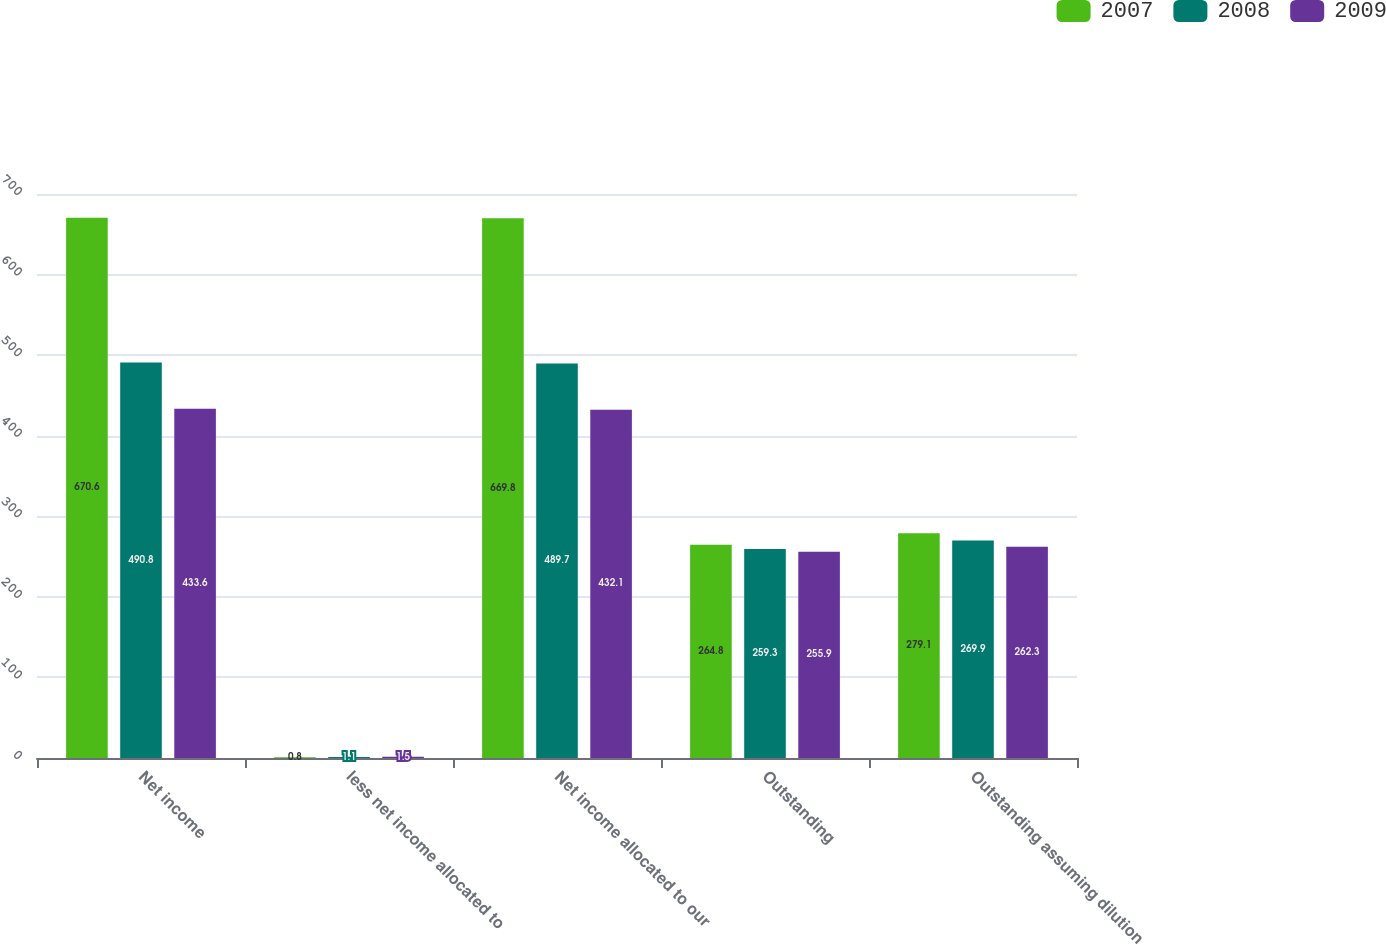Convert chart to OTSL. <chart><loc_0><loc_0><loc_500><loc_500><stacked_bar_chart><ecel><fcel>Net income<fcel>less net income allocated to<fcel>Net income allocated to our<fcel>Outstanding<fcel>Outstanding assuming dilution<nl><fcel>2007<fcel>670.6<fcel>0.8<fcel>669.8<fcel>264.8<fcel>279.1<nl><fcel>2008<fcel>490.8<fcel>1.1<fcel>489.7<fcel>259.3<fcel>269.9<nl><fcel>2009<fcel>433.6<fcel>1.5<fcel>432.1<fcel>255.9<fcel>262.3<nl></chart> 